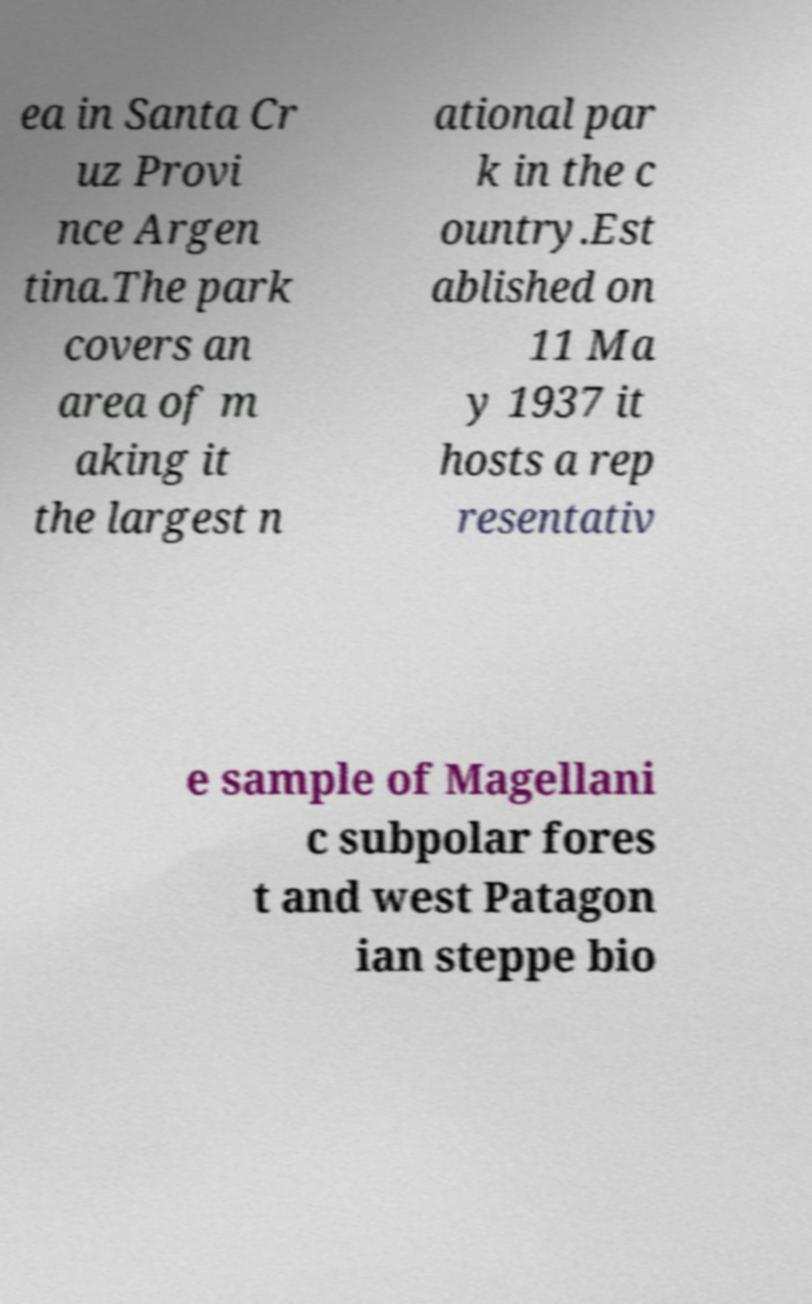What messages or text are displayed in this image? I need them in a readable, typed format. ea in Santa Cr uz Provi nce Argen tina.The park covers an area of m aking it the largest n ational par k in the c ountry.Est ablished on 11 Ma y 1937 it hosts a rep resentativ e sample of Magellani c subpolar fores t and west Patagon ian steppe bio 